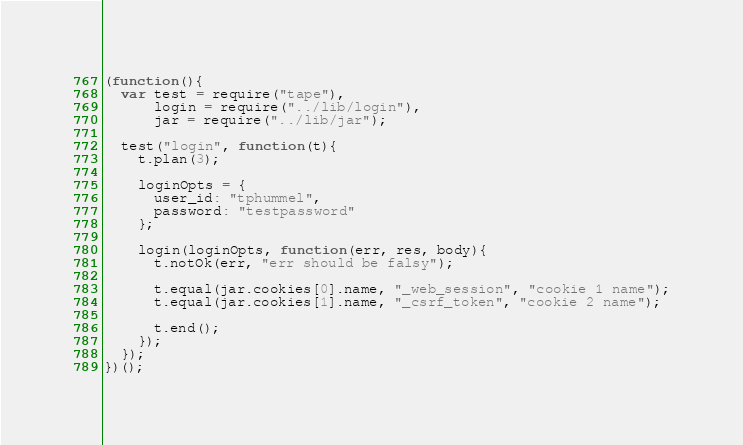<code> <loc_0><loc_0><loc_500><loc_500><_JavaScript_>(function(){
  var test = require("tape"),
      login = require("../lib/login"),
      jar = require("../lib/jar");

  test("login", function(t){
    t.plan(3);

    loginOpts = {
      user_id: "tphummel",
      password: "testpassword"
    };

    login(loginOpts, function(err, res, body){
      t.notOk(err, "err should be falsy");
      
      t.equal(jar.cookies[0].name, "_web_session", "cookie 1 name");
      t.equal(jar.cookies[1].name, "_csrf_token", "cookie 2 name");
      
      t.end();
    });
  });
})();</code> 